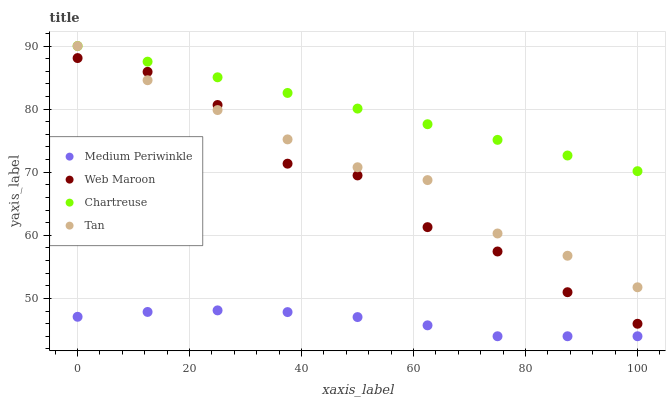Does Medium Periwinkle have the minimum area under the curve?
Answer yes or no. Yes. Does Chartreuse have the maximum area under the curve?
Answer yes or no. Yes. Does Chartreuse have the minimum area under the curve?
Answer yes or no. No. Does Medium Periwinkle have the maximum area under the curve?
Answer yes or no. No. Is Chartreuse the smoothest?
Answer yes or no. Yes. Is Web Maroon the roughest?
Answer yes or no. Yes. Is Medium Periwinkle the smoothest?
Answer yes or no. No. Is Medium Periwinkle the roughest?
Answer yes or no. No. Does Medium Periwinkle have the lowest value?
Answer yes or no. Yes. Does Chartreuse have the lowest value?
Answer yes or no. No. Does Tan have the highest value?
Answer yes or no. Yes. Does Medium Periwinkle have the highest value?
Answer yes or no. No. Is Medium Periwinkle less than Web Maroon?
Answer yes or no. Yes. Is Chartreuse greater than Web Maroon?
Answer yes or no. Yes. Does Web Maroon intersect Tan?
Answer yes or no. Yes. Is Web Maroon less than Tan?
Answer yes or no. No. Is Web Maroon greater than Tan?
Answer yes or no. No. Does Medium Periwinkle intersect Web Maroon?
Answer yes or no. No. 